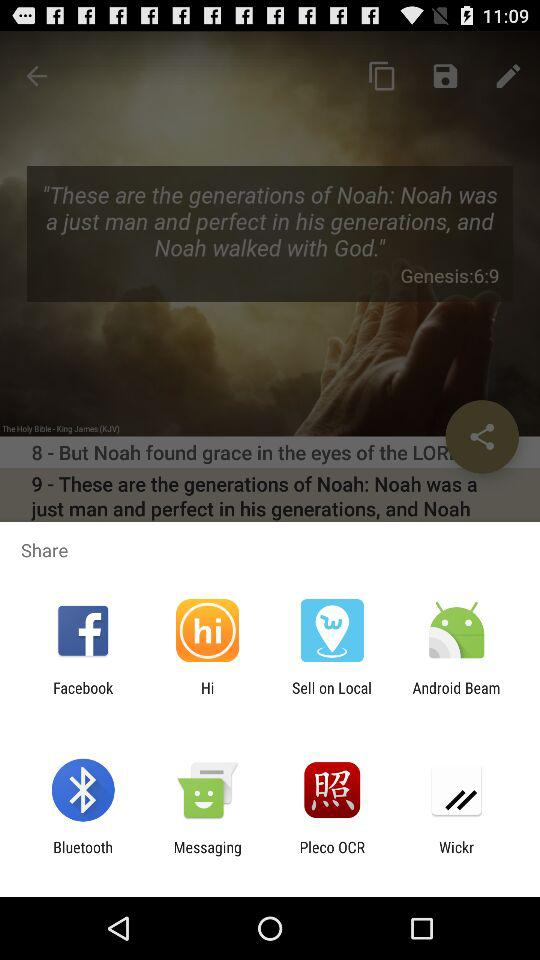Which are the different sharing options? The different sharing options are "Facebook", "Hi", "Sell on Local", "Android Beam", "Bluetooth", "Messaging", "Pleco OCR" and "Wickr". 